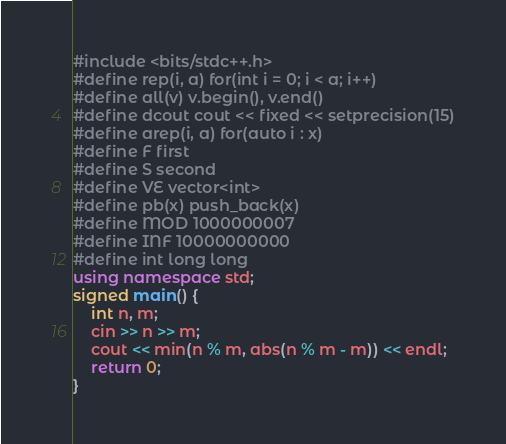Convert code to text. <code><loc_0><loc_0><loc_500><loc_500><_C++_>#include <bits/stdc++.h>
#define rep(i, a) for(int i = 0; i < a; i++)
#define all(v) v.begin(), v.end()
#define dcout cout << fixed << setprecision(15)
#define arep(i, a) for(auto i : x)
#define F first
#define S second
#define VE vector<int>
#define pb(x) push_back(x)
#define MOD 1000000007
#define INF 10000000000
#define int long long
using namespace std;
signed main() {
    int n, m;
    cin >> n >> m;
    cout << min(n % m, abs(n % m - m)) << endl;
    return 0;
}</code> 